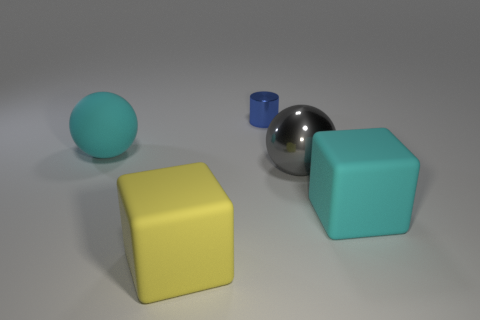Add 5 cyan metal things. How many objects exist? 10 Subtract all yellow cubes. How many cubes are left? 1 Subtract all spheres. How many objects are left? 3 Subtract all purple balls. Subtract all green blocks. How many balls are left? 2 Subtract all red spheres. How many brown cylinders are left? 0 Subtract all tiny green matte balls. Subtract all rubber things. How many objects are left? 2 Add 2 big rubber spheres. How many big rubber spheres are left? 3 Add 1 yellow matte things. How many yellow matte things exist? 2 Subtract 1 gray balls. How many objects are left? 4 